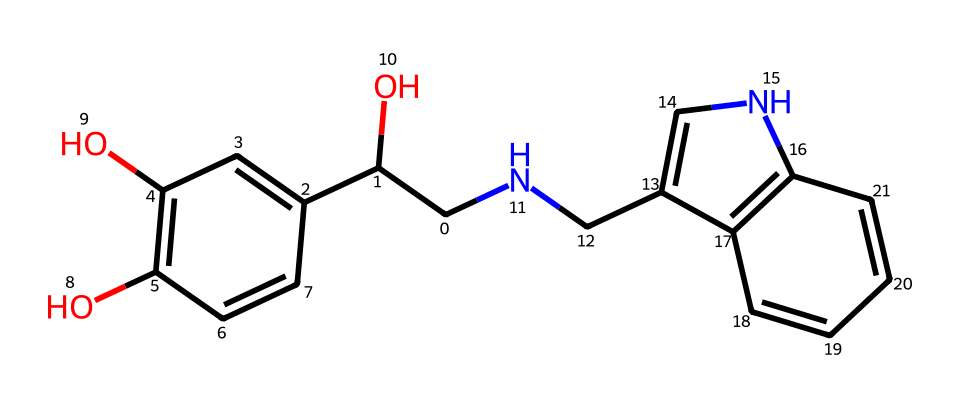What is the molecular formula of adrenaline? To find the molecular formula, count the number of carbon (C), hydrogen (H), nitrogen (N), and oxygen (O) atoms in the structure. There are 9 C, 13 H, 1 N, and 3 O atoms, which gives the molecular formula C9H13NO3.
Answer: C9H13NO3 How many rings are present in the structure of adrenaline? Examining the chemical structure, we see that there are two fused rings in the molecule, which can be identified by the interconnected carbon atoms.
Answer: 2 What functional groups are present in adrenaline? By analyzing the structure, we identify the two hydroxyl groups (-OH) and an amine group (-NH) which are characteristic functional groups in adrenaline.
Answer: hydroxyl and amine What is the role of adrenaline in the body? Adrenaline is involved in the "fight or flight" response, where it prepares the body for rapid action in stressful situations.
Answer: stress response Which element in the structure indicates it is a hormone? The presence of nitrogen (N) indicates that it is a hormone, as many hormones are formed from amino acids that contain nitrogen.
Answer: nitrogen How does the chemical structure relate to its function as a hormone? The structure of adrenaline, including its rings and functional groups, allows it to easily interact with specific receptors in the body, facilitating rapid physiological responses such as increased heart rate and energy mobilization.
Answer: receptor interaction 